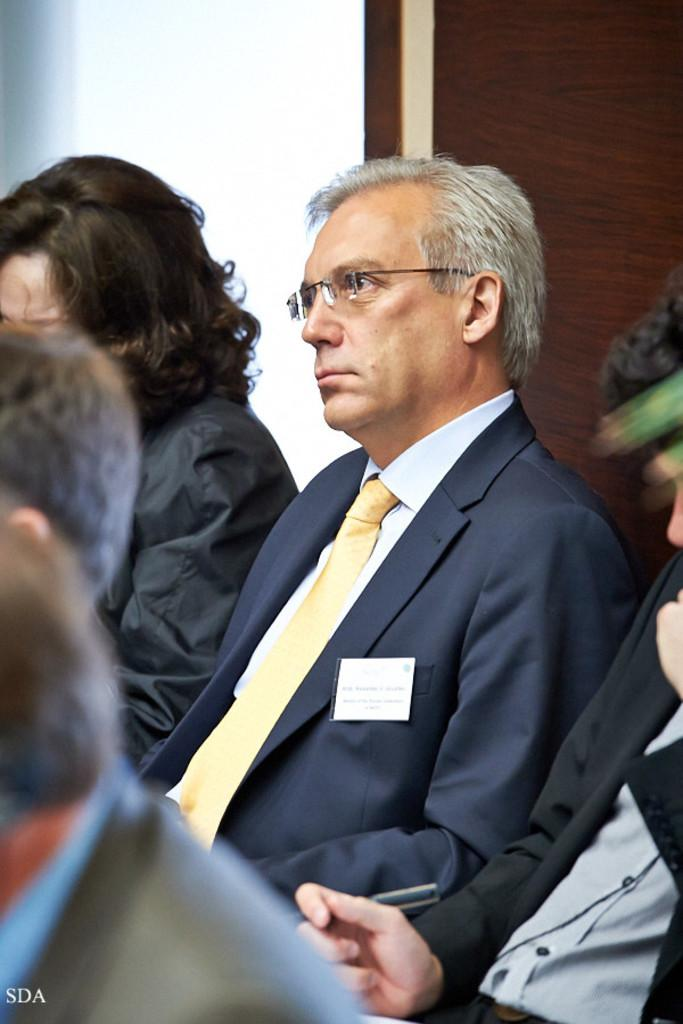Who or what is present in the image? There are people in the image. What can be seen in the background of the image? There is a wall visible in the background of the image. What type of activity are the ants participating in within the image? There are no ants present in the image. What need do the people in the image have that is not visible in the image? There is no information provided about any unmet needs of the people in the image. 